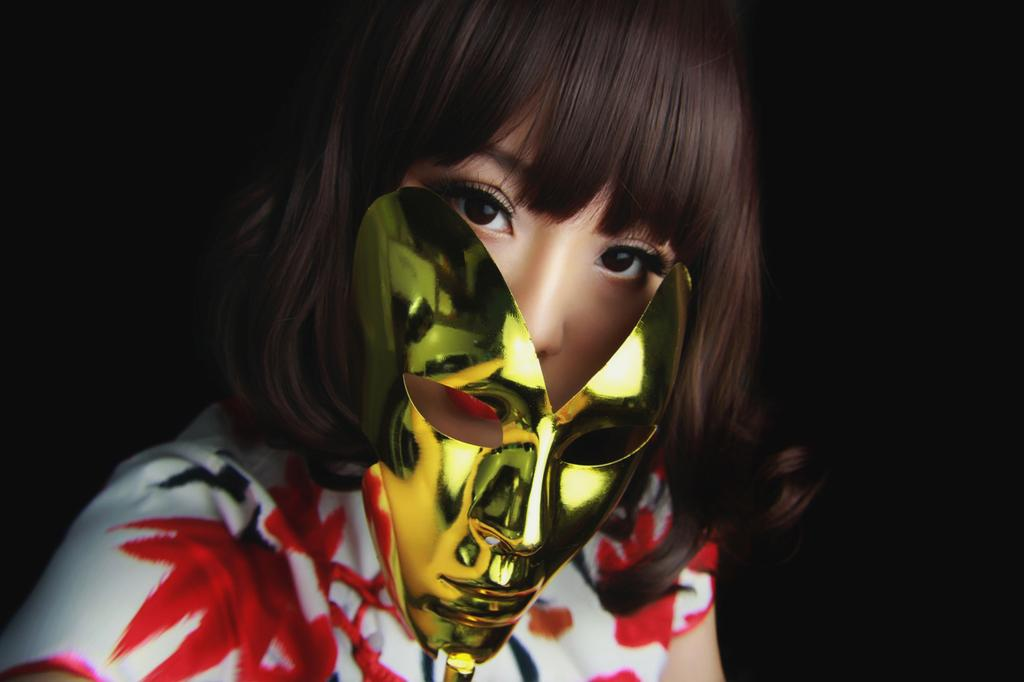What is the main subject of the image? The main subject of the image is a person. What is the person wearing in the image? The person is wearing a mask in the image. What is the color of the background in the image? The background of the image is dark. What type of observation can be made about the person's action in the image? There is no specific action being performed by the person in the image, so it is not possible to make an observation about their action. 